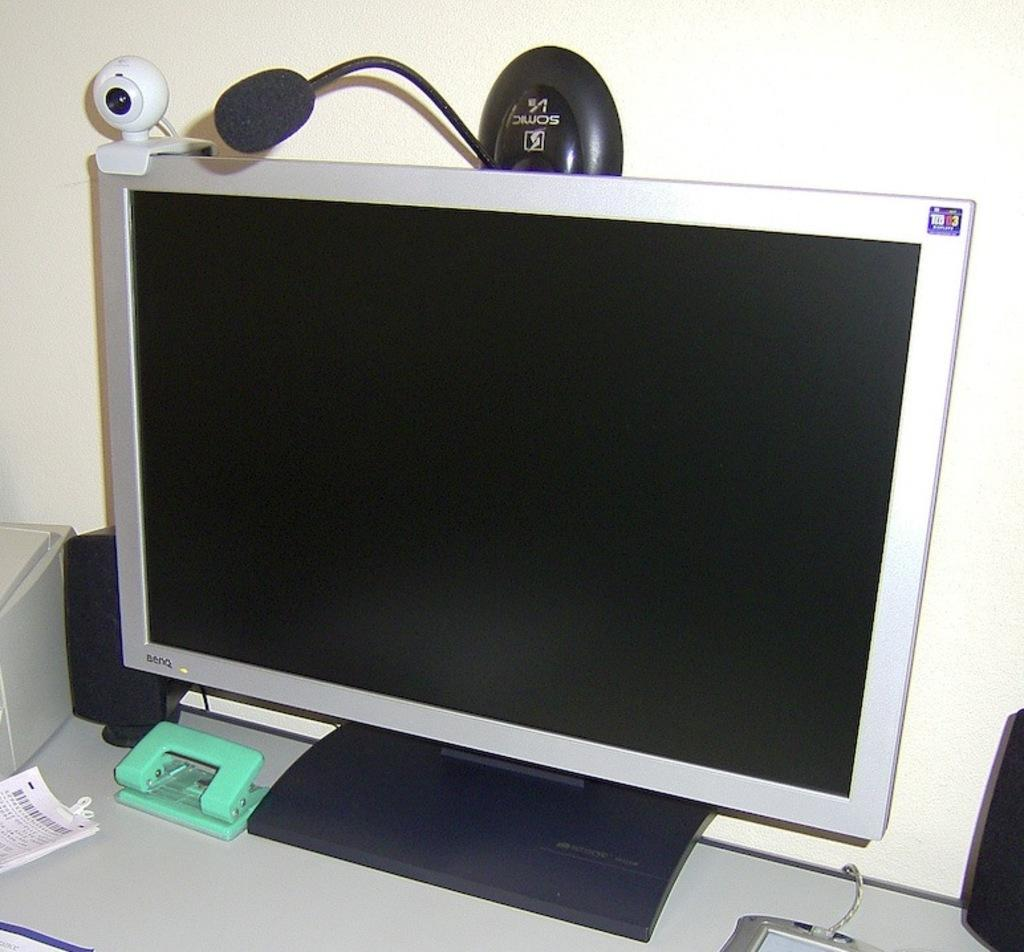<image>
Present a compact description of the photo's key features. A Somic brand microphone is attached to the top of a computer monitor. 